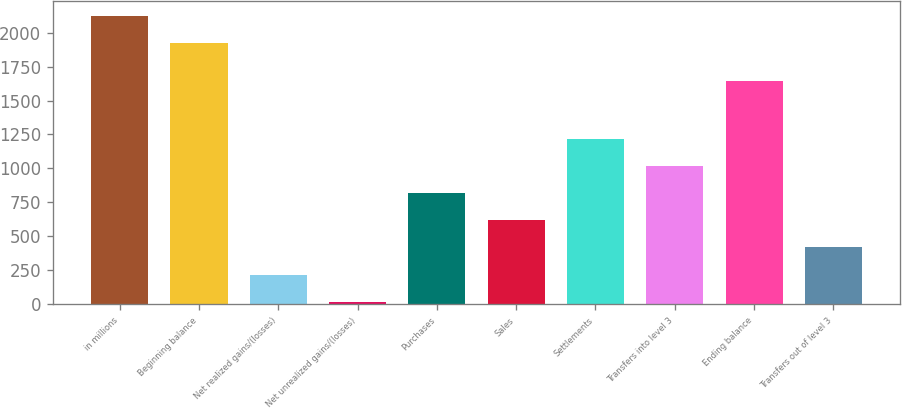Convert chart to OTSL. <chart><loc_0><loc_0><loc_500><loc_500><bar_chart><fcel>in millions<fcel>Beginning balance<fcel>Net realized gains/(losses)<fcel>Net unrealized gains/(losses)<fcel>Purchases<fcel>Sales<fcel>Settlements<fcel>Transfers into level 3<fcel>Ending balance<fcel>Transfers out of level 3<nl><fcel>2123.7<fcel>1924<fcel>218.7<fcel>19<fcel>817.8<fcel>618.1<fcel>1217.2<fcel>1017.5<fcel>1645<fcel>418.4<nl></chart> 